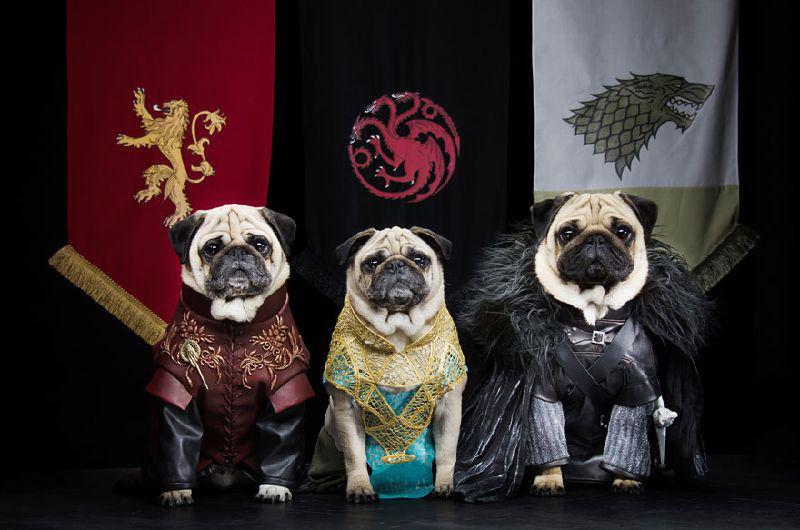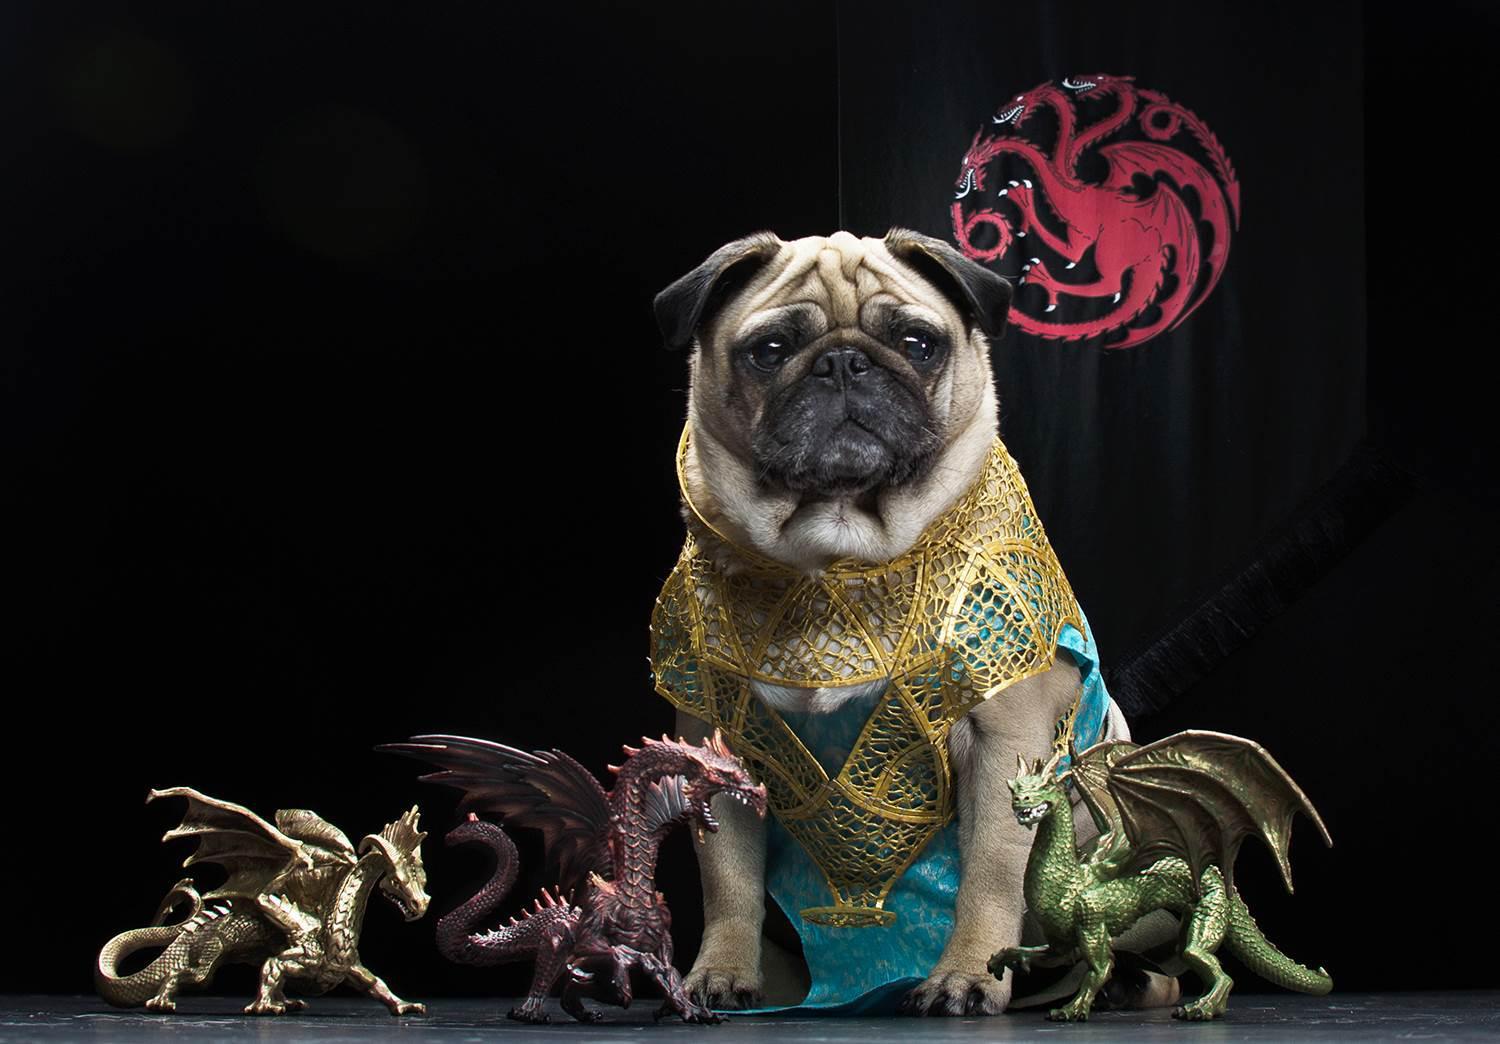The first image is the image on the left, the second image is the image on the right. For the images displayed, is the sentence "Three small dogs stand next to each other dressed in costume." factually correct? Answer yes or no. Yes. The first image is the image on the left, the second image is the image on the right. Evaluate the accuracy of this statement regarding the images: "There are at least four dressed up pugs.". Is it true? Answer yes or no. Yes. 